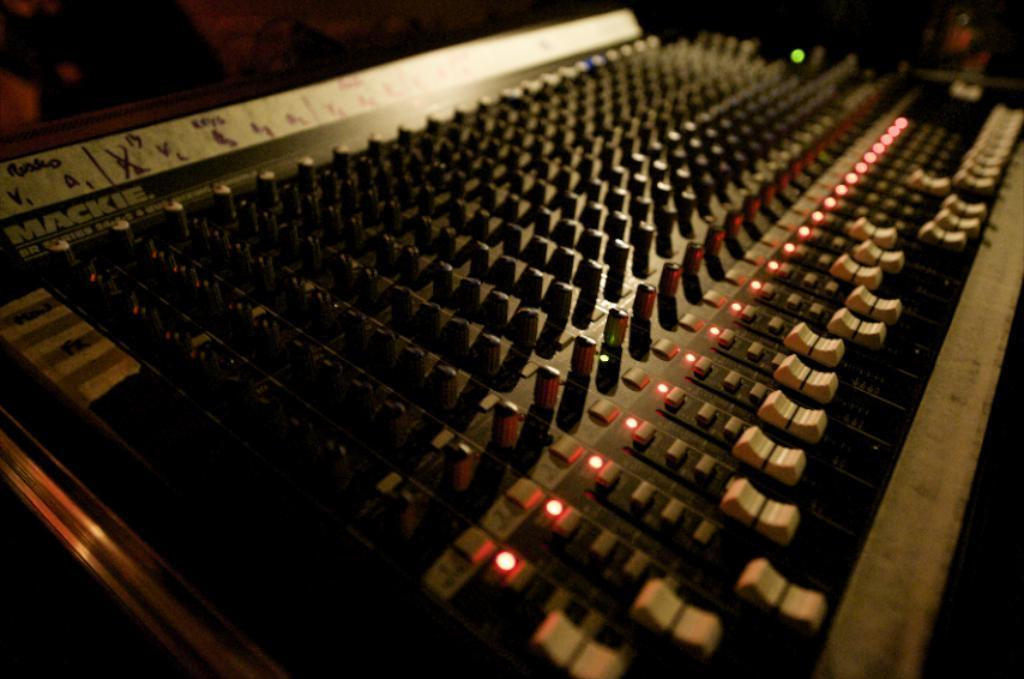What object in the image is used to create music? There is a musical instrument in the image. What can be observed about the lighting in the image? The background of the image is dark. What type of hammer is being used to create a quiet sound in the image? There is no hammer or sound present in the image; it only features a musical instrument. 